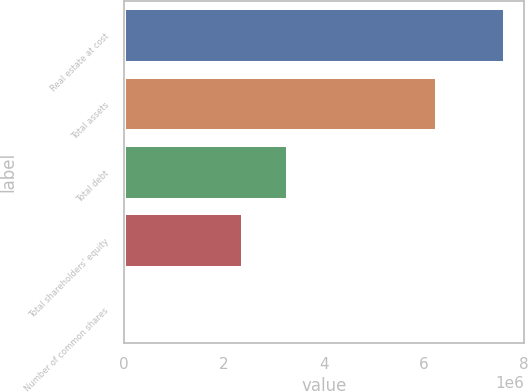<chart> <loc_0><loc_0><loc_500><loc_500><bar_chart><fcel>Real estate at cost<fcel>Total assets<fcel>Total debt<fcel>Total shareholders' equity<fcel>Number of common shares<nl><fcel>7.63506e+06<fcel>6.27576e+06<fcel>3.28477e+06<fcel>2.39151e+06<fcel>73091<nl></chart> 